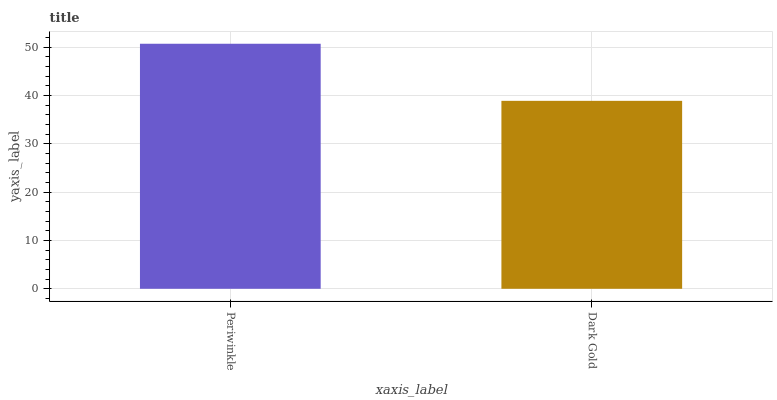Is Dark Gold the minimum?
Answer yes or no. Yes. Is Periwinkle the maximum?
Answer yes or no. Yes. Is Dark Gold the maximum?
Answer yes or no. No. Is Periwinkle greater than Dark Gold?
Answer yes or no. Yes. Is Dark Gold less than Periwinkle?
Answer yes or no. Yes. Is Dark Gold greater than Periwinkle?
Answer yes or no. No. Is Periwinkle less than Dark Gold?
Answer yes or no. No. Is Periwinkle the high median?
Answer yes or no. Yes. Is Dark Gold the low median?
Answer yes or no. Yes. Is Dark Gold the high median?
Answer yes or no. No. Is Periwinkle the low median?
Answer yes or no. No. 